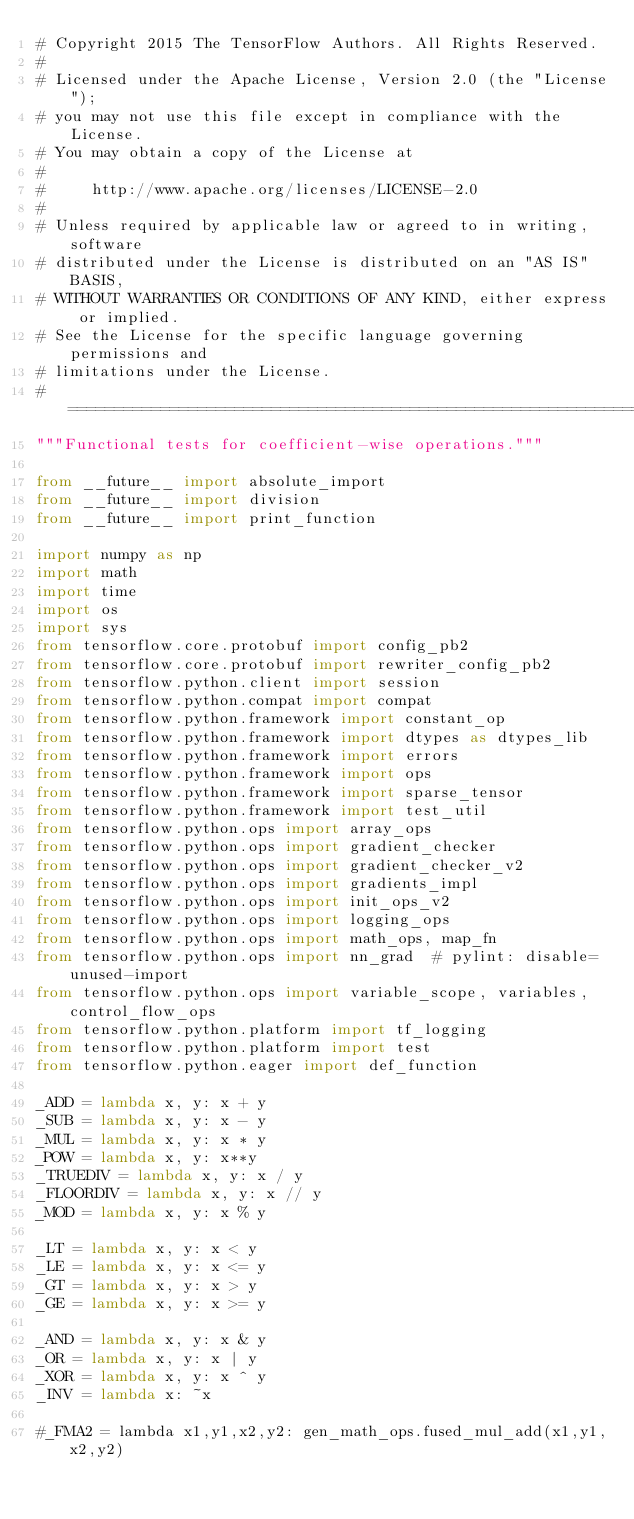Convert code to text. <code><loc_0><loc_0><loc_500><loc_500><_Python_># Copyright 2015 The TensorFlow Authors. All Rights Reserved.
#
# Licensed under the Apache License, Version 2.0 (the "License");
# you may not use this file except in compliance with the License.
# You may obtain a copy of the License at
#
#     http://www.apache.org/licenses/LICENSE-2.0
#
# Unless required by applicable law or agreed to in writing, software
# distributed under the License is distributed on an "AS IS" BASIS,
# WITHOUT WARRANTIES OR CONDITIONS OF ANY KIND, either express or implied.
# See the License for the specific language governing permissions and
# limitations under the License.
# ==============================================================================
"""Functional tests for coefficient-wise operations."""

from __future__ import absolute_import
from __future__ import division
from __future__ import print_function

import numpy as np
import math
import time
import os
import sys
from tensorflow.core.protobuf import config_pb2
from tensorflow.core.protobuf import rewriter_config_pb2
from tensorflow.python.client import session
from tensorflow.python.compat import compat
from tensorflow.python.framework import constant_op
from tensorflow.python.framework import dtypes as dtypes_lib
from tensorflow.python.framework import errors
from tensorflow.python.framework import ops
from tensorflow.python.framework import sparse_tensor
from tensorflow.python.framework import test_util
from tensorflow.python.ops import array_ops
from tensorflow.python.ops import gradient_checker
from tensorflow.python.ops import gradient_checker_v2
from tensorflow.python.ops import gradients_impl
from tensorflow.python.ops import init_ops_v2
from tensorflow.python.ops import logging_ops
from tensorflow.python.ops import math_ops, map_fn
from tensorflow.python.ops import nn_grad  # pylint: disable=unused-import
from tensorflow.python.ops import variable_scope, variables, control_flow_ops
from tensorflow.python.platform import tf_logging
from tensorflow.python.platform import test
from tensorflow.python.eager import def_function

_ADD = lambda x, y: x + y
_SUB = lambda x, y: x - y
_MUL = lambda x, y: x * y
_POW = lambda x, y: x**y
_TRUEDIV = lambda x, y: x / y
_FLOORDIV = lambda x, y: x // y
_MOD = lambda x, y: x % y

_LT = lambda x, y: x < y
_LE = lambda x, y: x <= y
_GT = lambda x, y: x > y
_GE = lambda x, y: x >= y

_AND = lambda x, y: x & y
_OR = lambda x, y: x | y
_XOR = lambda x, y: x ^ y
_INV = lambda x: ~x

#_FMA2 = lambda x1,y1,x2,y2: gen_math_ops.fused_mul_add(x1,y1,x2,y2)</code> 